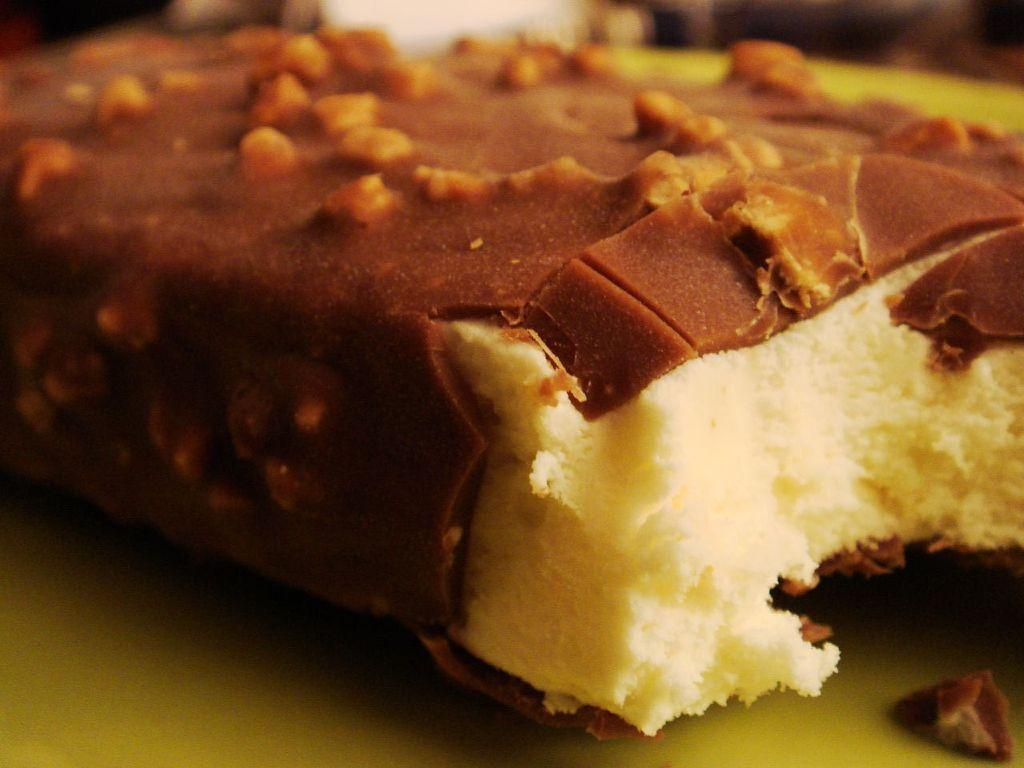What type of food can be seen in the image? The image contains food, but the specific type cannot be determined from the provided facts. Can you describe the colors of the food in the image? The food has brown and cream colors. What is the color of the surface on which the food is placed? The food is on a yellow surface. What religion is being practiced in the image? There is no indication of any religious practice or symbol in the image. 